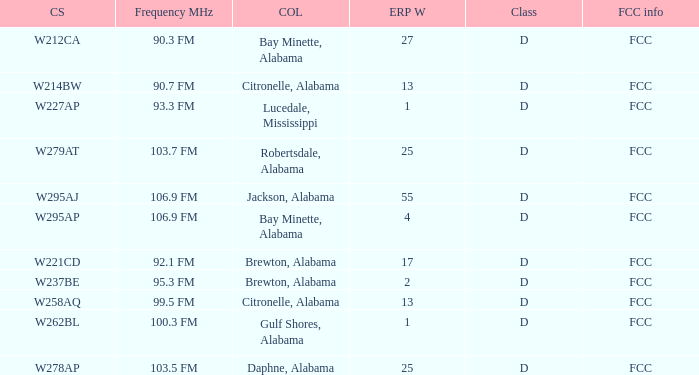Identify the mhz frequency for an erp with 55 w power. 106.9 FM. 